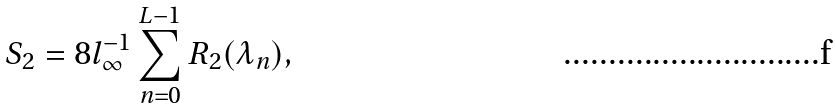<formula> <loc_0><loc_0><loc_500><loc_500>S _ { 2 } = 8 l _ { \infty } ^ { - 1 } \sum _ { n = 0 } ^ { L - 1 } R _ { 2 } ( \lambda _ { n } ) ,</formula> 